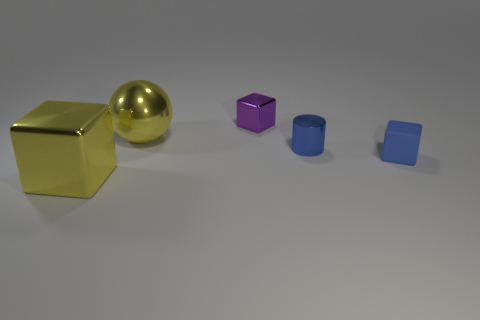Do the shiny ball and the blue matte thing have the same size?
Offer a very short reply. No. What is the material of the small blue cylinder?
Keep it short and to the point. Metal. There is a cylinder that is the same color as the small rubber block; what is it made of?
Your answer should be very brief. Metal. Does the thing in front of the blue rubber object have the same shape as the purple metal object?
Your response must be concise. Yes. What number of things are either large metal things or tiny metal objects?
Offer a terse response. 4. Is the big yellow ball on the left side of the tiny shiny block made of the same material as the large cube?
Make the answer very short. Yes. How big is the yellow sphere?
Keep it short and to the point. Large. What shape is the metallic object that is the same color as the matte block?
Make the answer very short. Cylinder. What number of balls are either blue shiny things or big yellow objects?
Offer a terse response. 1. Are there the same number of purple things that are on the left side of the small purple thing and tiny blue blocks in front of the blue metal cylinder?
Ensure brevity in your answer.  No. 